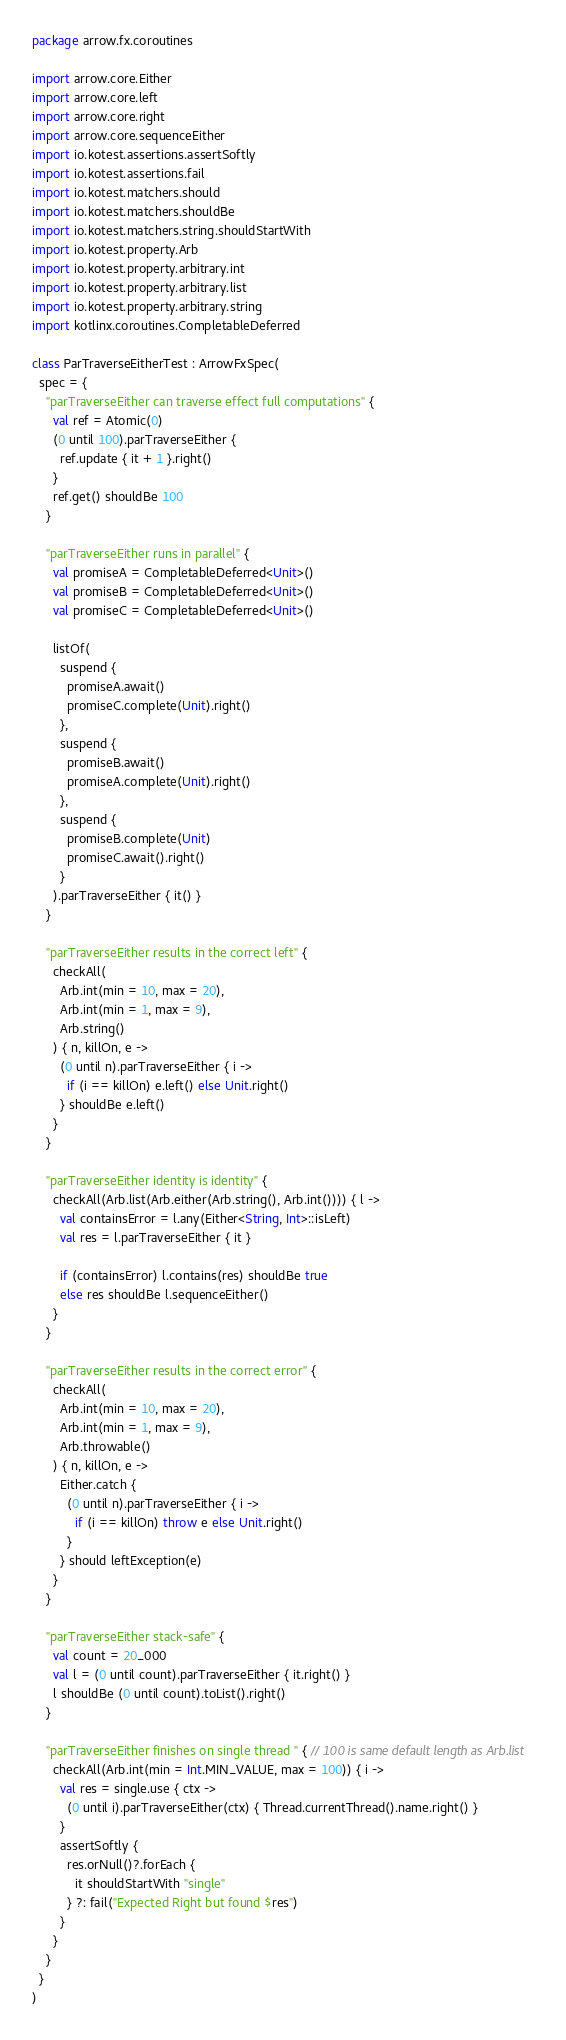Convert code to text. <code><loc_0><loc_0><loc_500><loc_500><_Kotlin_>package arrow.fx.coroutines

import arrow.core.Either
import arrow.core.left
import arrow.core.right
import arrow.core.sequenceEither
import io.kotest.assertions.assertSoftly
import io.kotest.assertions.fail
import io.kotest.matchers.should
import io.kotest.matchers.shouldBe
import io.kotest.matchers.string.shouldStartWith
import io.kotest.property.Arb
import io.kotest.property.arbitrary.int
import io.kotest.property.arbitrary.list
import io.kotest.property.arbitrary.string
import kotlinx.coroutines.CompletableDeferred

class ParTraverseEitherTest : ArrowFxSpec(
  spec = {
    "parTraverseEither can traverse effect full computations" {
      val ref = Atomic(0)
      (0 until 100).parTraverseEither {
        ref.update { it + 1 }.right()
      }
      ref.get() shouldBe 100
    }

    "parTraverseEither runs in parallel" {
      val promiseA = CompletableDeferred<Unit>()
      val promiseB = CompletableDeferred<Unit>()
      val promiseC = CompletableDeferred<Unit>()

      listOf(
        suspend {
          promiseA.await()
          promiseC.complete(Unit).right()
        },
        suspend {
          promiseB.await()
          promiseA.complete(Unit).right()
        },
        suspend {
          promiseB.complete(Unit)
          promiseC.await().right()
        }
      ).parTraverseEither { it() }
    }

    "parTraverseEither results in the correct left" {
      checkAll(
        Arb.int(min = 10, max = 20),
        Arb.int(min = 1, max = 9),
        Arb.string()
      ) { n, killOn, e ->
        (0 until n).parTraverseEither { i ->
          if (i == killOn) e.left() else Unit.right()
        } shouldBe e.left()
      }
    }

    "parTraverseEither identity is identity" {
      checkAll(Arb.list(Arb.either(Arb.string(), Arb.int()))) { l ->
        val containsError = l.any(Either<String, Int>::isLeft)
        val res = l.parTraverseEither { it }

        if (containsError) l.contains(res) shouldBe true
        else res shouldBe l.sequenceEither()
      }
    }

    "parTraverseEither results in the correct error" {
      checkAll(
        Arb.int(min = 10, max = 20),
        Arb.int(min = 1, max = 9),
        Arb.throwable()
      ) { n, killOn, e ->
        Either.catch {
          (0 until n).parTraverseEither { i ->
            if (i == killOn) throw e else Unit.right()
          }
        } should leftException(e)
      }
    }

    "parTraverseEither stack-safe" {
      val count = 20_000
      val l = (0 until count).parTraverseEither { it.right() }
      l shouldBe (0 until count).toList().right()
    }

    "parTraverseEither finishes on single thread " { // 100 is same default length as Arb.list
      checkAll(Arb.int(min = Int.MIN_VALUE, max = 100)) { i ->
        val res = single.use { ctx ->
          (0 until i).parTraverseEither(ctx) { Thread.currentThread().name.right() }
        }
        assertSoftly {
          res.orNull()?.forEach {
            it shouldStartWith "single"
          } ?: fail("Expected Right but found $res")
        }
      }
    }
  }
)
</code> 